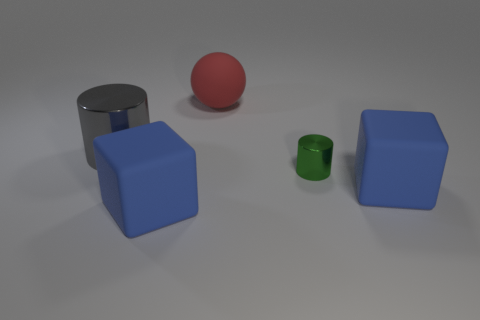Add 3 red matte things. How many objects exist? 8 Subtract all brown cylinders. How many cyan spheres are left? 0 Add 1 shiny things. How many shiny things are left? 3 Add 1 green spheres. How many green spheres exist? 1 Subtract 1 gray cylinders. How many objects are left? 4 Subtract all cylinders. How many objects are left? 3 Subtract 2 cubes. How many cubes are left? 0 Subtract all gray cylinders. Subtract all yellow spheres. How many cylinders are left? 1 Subtract all red things. Subtract all cyan spheres. How many objects are left? 4 